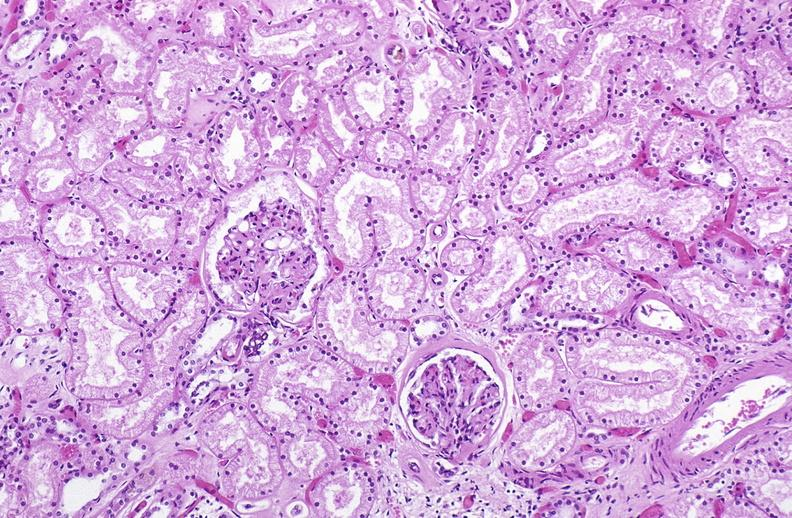where is this?
Answer the question using a single word or phrase. Urinary 